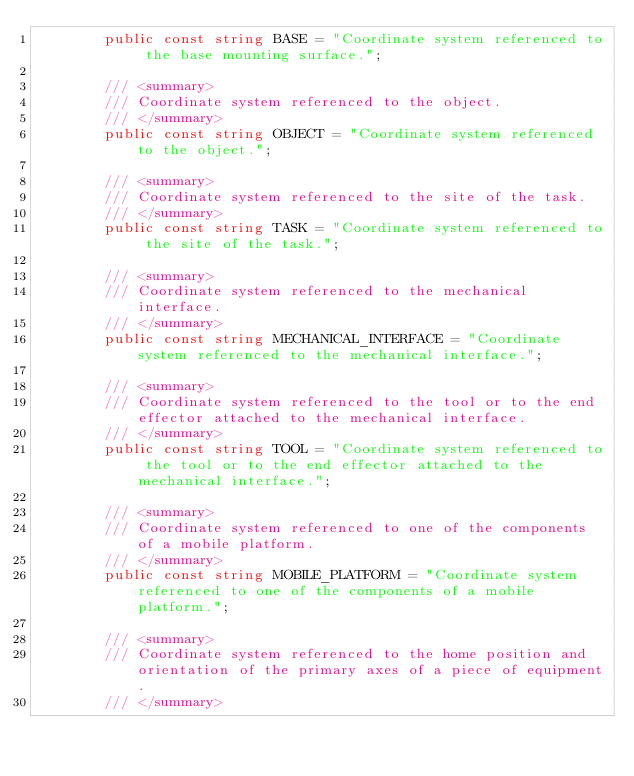Convert code to text. <code><loc_0><loc_0><loc_500><loc_500><_C#_>        public const string BASE = "Coordinate system referenced to the base mounting surface.";

        /// <summary>
        /// Coordinate system referenced to the object.
        /// </summary>
        public const string OBJECT = "Coordinate system referenced to the object.";

        /// <summary>
        /// Coordinate system referenced to the site of the task.
        /// </summary>
        public const string TASK = "Coordinate system referenced to the site of the task.";

        /// <summary>
        /// Coordinate system referenced to the mechanical interface.
        /// </summary>
        public const string MECHANICAL_INTERFACE = "Coordinate system referenced to the mechanical interface.";

        /// <summary>
        /// Coordinate system referenced to the tool or to the end effector attached to the mechanical interface. 
        /// </summary>
        public const string TOOL = "Coordinate system referenced to the tool or to the end effector attached to the mechanical interface.";

        /// <summary>
        /// Coordinate system referenced to one of the components of a mobile platform.
        /// </summary>
        public const string MOBILE_PLATFORM = "Coordinate system referenced to one of the components of a mobile platform.";

        /// <summary>
        /// Coordinate system referenced to the home position and orientation of the primary axes of a piece of equipment.
        /// </summary></code> 